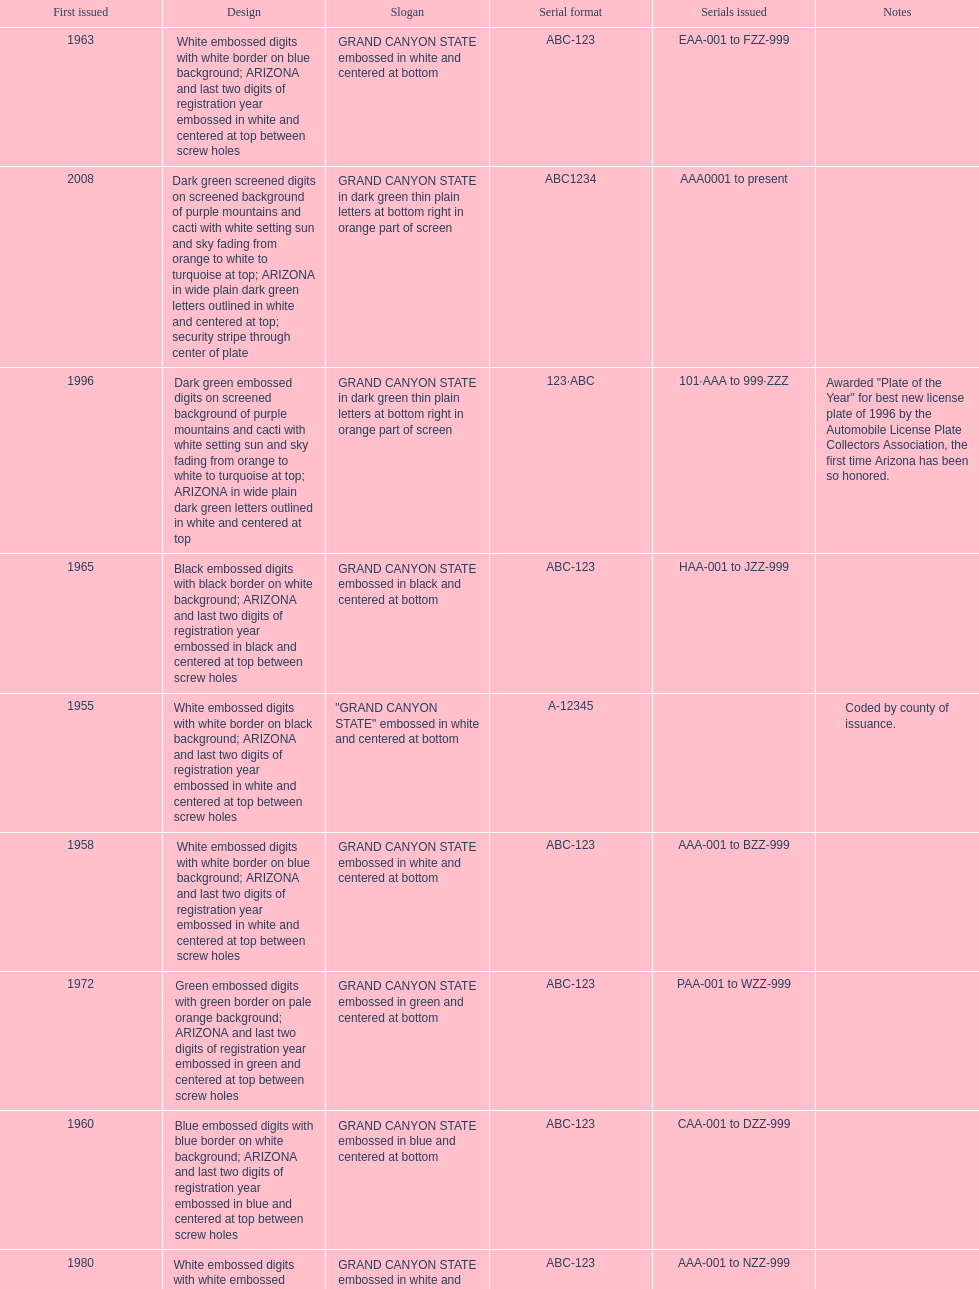Could you help me parse every detail presented in this table? {'header': ['First issued', 'Design', 'Slogan', 'Serial format', 'Serials issued', 'Notes'], 'rows': [['1963', 'White embossed digits with white border on blue background; ARIZONA and last two digits of registration year embossed in white and centered at top between screw holes', 'GRAND CANYON STATE embossed in white and centered at bottom', 'ABC-123', 'EAA-001 to FZZ-999', ''], ['2008', 'Dark green screened digits on screened background of purple mountains and cacti with white setting sun and sky fading from orange to white to turquoise at top; ARIZONA in wide plain dark green letters outlined in white and centered at top; security stripe through center of plate', 'GRAND CANYON STATE in dark green thin plain letters at bottom right in orange part of screen', 'ABC1234', 'AAA0001 to present', ''], ['1996', 'Dark green embossed digits on screened background of purple mountains and cacti with white setting sun and sky fading from orange to white to turquoise at top; ARIZONA in wide plain dark green letters outlined in white and centered at top', 'GRAND CANYON STATE in dark green thin plain letters at bottom right in orange part of screen', '123·ABC', '101·AAA to 999·ZZZ', 'Awarded "Plate of the Year" for best new license plate of 1996 by the Automobile License Plate Collectors Association, the first time Arizona has been so honored.'], ['1965', 'Black embossed digits with black border on white background; ARIZONA and last two digits of registration year embossed in black and centered at top between screw holes', 'GRAND CANYON STATE embossed in black and centered at bottom', 'ABC-123', 'HAA-001 to JZZ-999', ''], ['1955', 'White embossed digits with white border on black background; ARIZONA and last two digits of registration year embossed in white and centered at top between screw holes', '"GRAND CANYON STATE" embossed in white and centered at bottom', 'A-12345', '', 'Coded by county of issuance.'], ['1958', 'White embossed digits with white border on blue background; ARIZONA and last two digits of registration year embossed in white and centered at top between screw holes', 'GRAND CANYON STATE embossed in white and centered at bottom', 'ABC-123', 'AAA-001 to BZZ-999', ''], ['1972', 'Green embossed digits with green border on pale orange background; ARIZONA and last two digits of registration year embossed in green and centered at top between screw holes', 'GRAND CANYON STATE embossed in green and centered at bottom', 'ABC-123', 'PAA-001 to WZZ-999', ''], ['1960', 'Blue embossed digits with blue border on white background; ARIZONA and last two digits of registration year embossed in blue and centered at top between screw holes', 'GRAND CANYON STATE embossed in blue and centered at bottom', 'ABC-123', 'CAA-001 to DZZ-999', ''], ['1980', 'White embossed digits with white embossed border on maroon background, with white embossed saguaro cactus dividing the letters and numbers; ARIZONA embossed in white and centered at top', 'GRAND CANYON STATE embossed in white and centered at bottom', 'ABC-123', 'AAA-001 to NZZ-999', ''], ['1968', 'Black embossed digits with black border on yellow background; ARIZONA and last two digits of registration year embossed in black and centered at top between screw holes', 'GRAND CANYON STATE embossed in black and centered at bottom', 'ABC-123', 'KAA-001 to NZZ-999', '']]} What is the average serial format of the arizona license plates? ABC-123. 